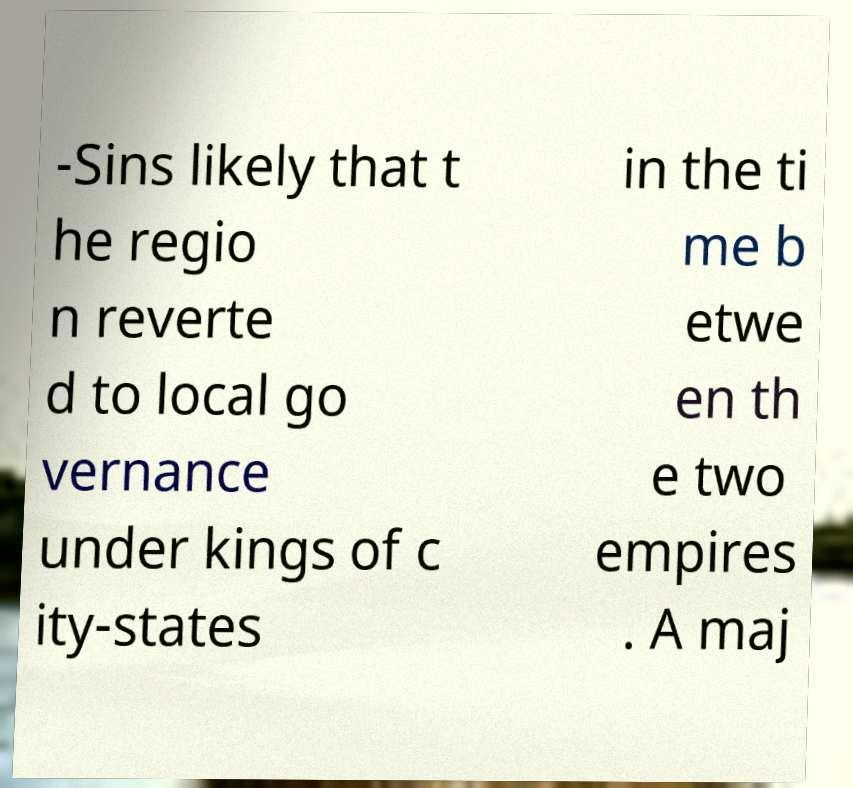There's text embedded in this image that I need extracted. Can you transcribe it verbatim? -Sins likely that t he regio n reverte d to local go vernance under kings of c ity-states in the ti me b etwe en th e two empires . A maj 